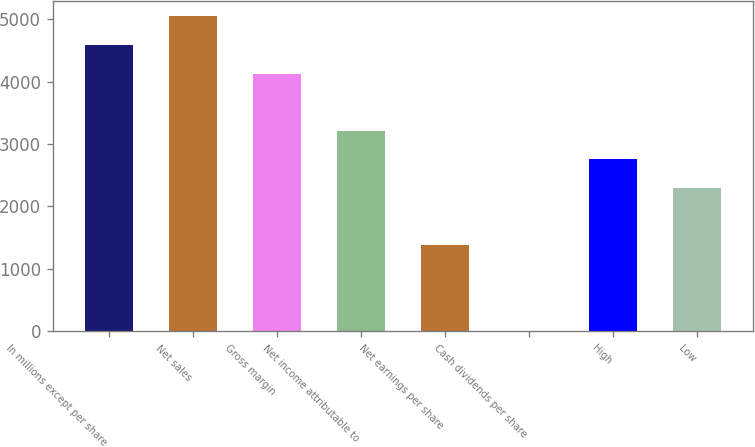Convert chart to OTSL. <chart><loc_0><loc_0><loc_500><loc_500><bar_chart><fcel>In millions except per share<fcel>Net sales<fcel>Gross margin<fcel>Net income attributable to<fcel>Net earnings per share<fcel>Cash dividends per share<fcel>High<fcel>Low<nl><fcel>4588.02<fcel>5046.76<fcel>4129.28<fcel>3211.8<fcel>1376.84<fcel>0.62<fcel>2753.06<fcel>2294.32<nl></chart> 